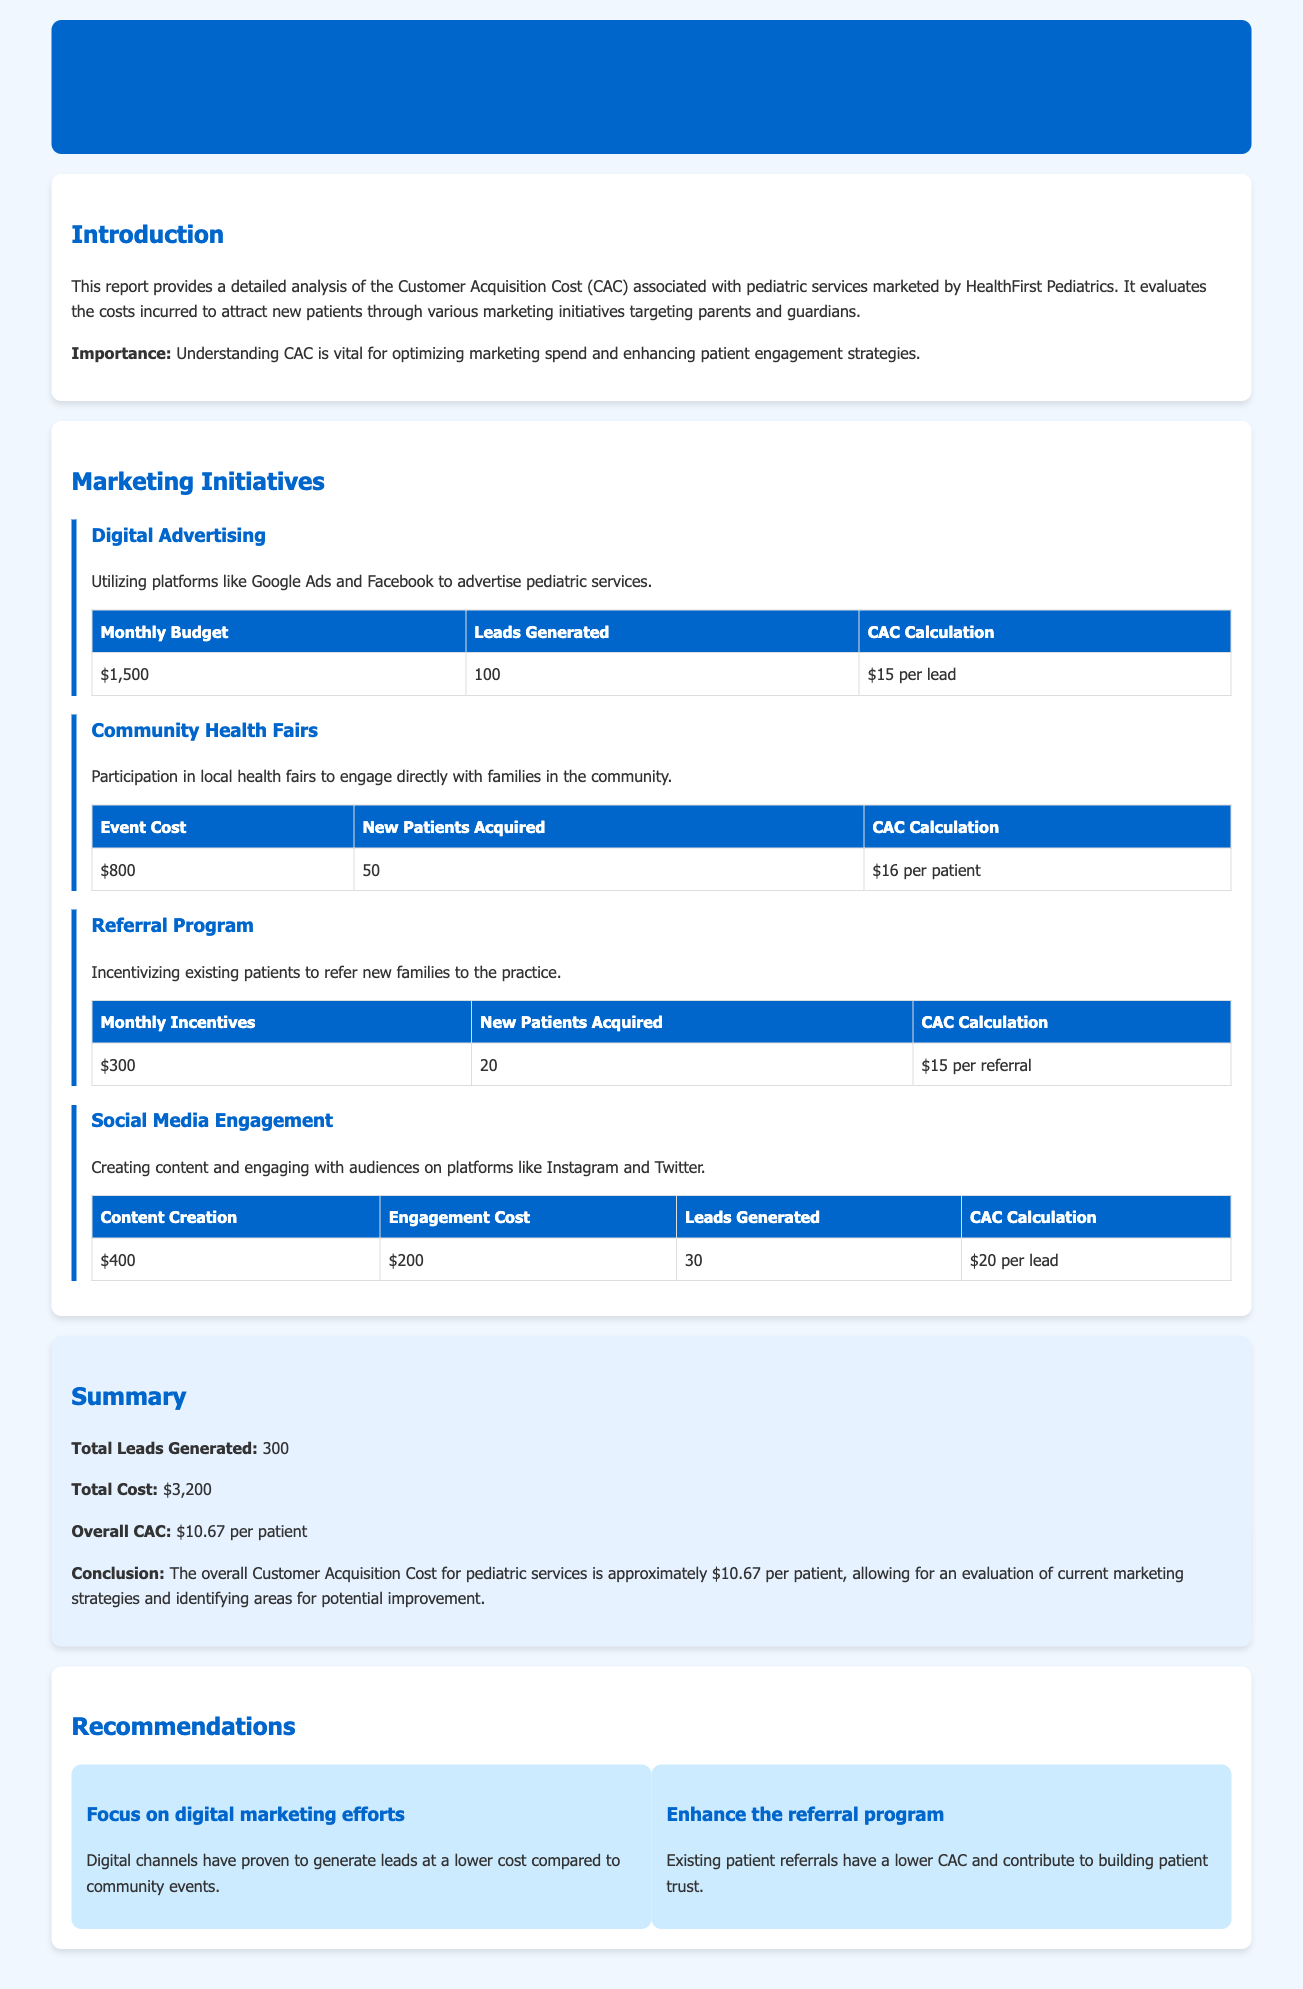What is the overall CAC for pediatric services? The overall CAC is calculated based on the total cost divided by the total leads generated, which is approximately $10.67 per patient.
Answer: $10.67 How many new patients were acquired through community health fairs? The number of new patients acquired is specified in the community health fairs initiative as 50.
Answer: 50 What is the total cost incurred for digital advertising? The monthly budget for digital advertising is mentioned as $1,500.
Answer: $1,500 Which marketing initiative generated the most leads? The total leads generated from digital advertising is the highest at 100.
Answer: Digital Advertising What is the cost per referral in the referral program? The CAC calculation for the referral program indicates a cost of $15 per referral.
Answer: $15 How many leads were generated from social media engagement? The number of leads generated from social media engagement is stated as 30.
Answer: 30 Which marketing initiative has the lowest CAC? The referral program is noted for having a lower CAC at $15 per referral.
Answer: Referral Program What is the total number of leads generated across all initiatives? The summary indicates that the total leads generated from all initiatives is 300.
Answer: 300 What is one recommendation from the report? One recommendation emphasizes focusing on digital marketing efforts due to lower lead costs.
Answer: Focus on digital marketing efforts 